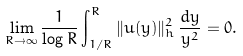<formula> <loc_0><loc_0><loc_500><loc_500>\lim _ { R \to \infty } \frac { 1 } { \log R } \int _ { 1 / R } ^ { R } \| u ( y ) \| _ { h } ^ { 2 } \, \frac { d y } { y ^ { 2 } } = 0 .</formula> 